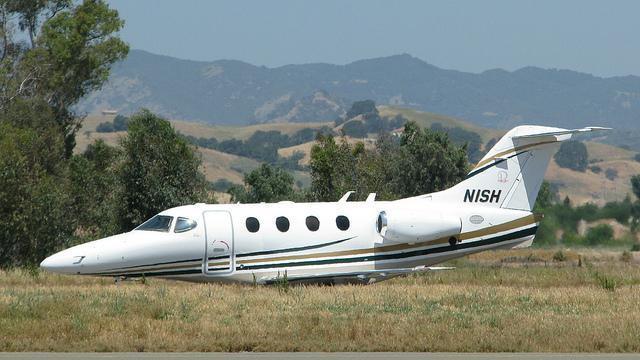How many windows are visible?
Give a very brief answer. 6. 